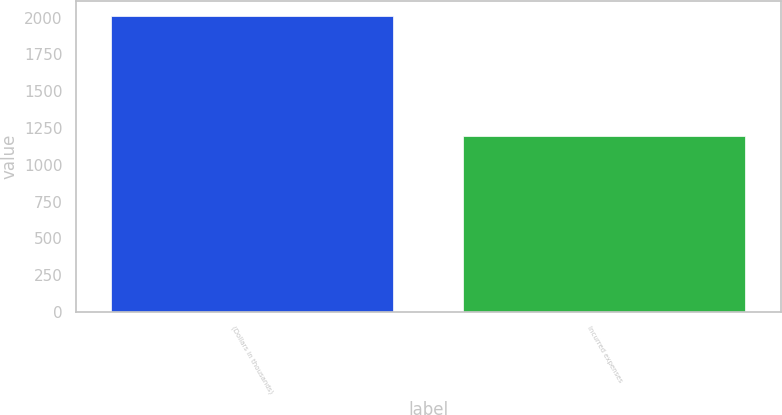<chart> <loc_0><loc_0><loc_500><loc_500><bar_chart><fcel>(Dollars in thousands)<fcel>Incurred expenses<nl><fcel>2013<fcel>1195<nl></chart> 